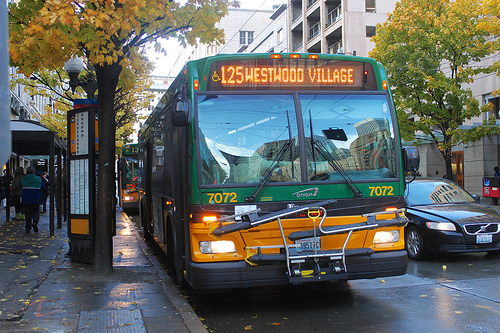How does the large vehicle look, dry or wet? The large vehicle in the image, which is a bus, appears distinctly dry despite the wet surroundings on the road. 